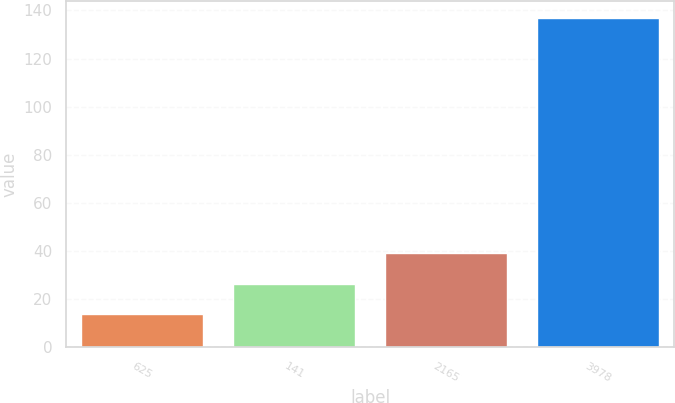Convert chart. <chart><loc_0><loc_0><loc_500><loc_500><bar_chart><fcel>625<fcel>141<fcel>2165<fcel>3978<nl><fcel>14<fcel>26.29<fcel>39.29<fcel>136.86<nl></chart> 